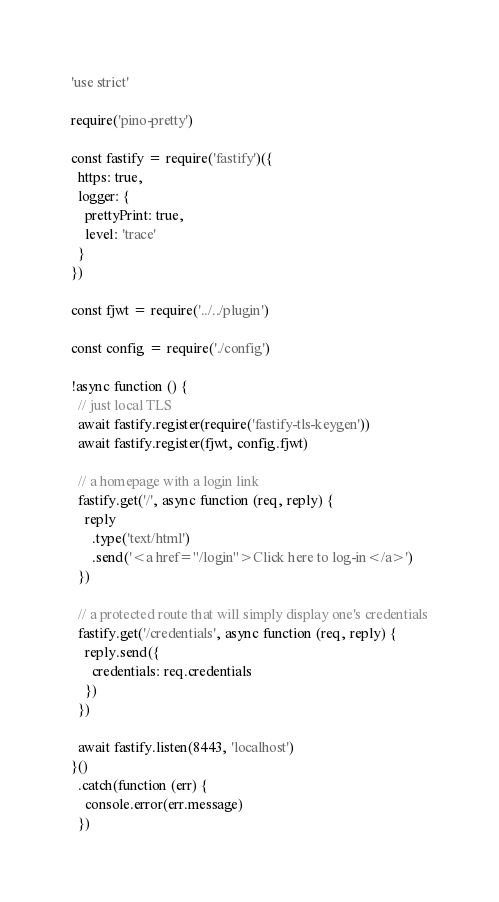<code> <loc_0><loc_0><loc_500><loc_500><_JavaScript_>'use strict'

require('pino-pretty')

const fastify = require('fastify')({
  https: true,
  logger: {
    prettyPrint: true,
    level: 'trace'
  }
})

const fjwt = require('../../plugin')

const config = require('./config')

!async function () {
  // just local TLS
  await fastify.register(require('fastify-tls-keygen'))
  await fastify.register(fjwt, config.fjwt)

  // a homepage with a login link
  fastify.get('/', async function (req, reply) {
    reply
      .type('text/html')
      .send('<a href="/login">Click here to log-in</a>')
  })

  // a protected route that will simply display one's credentials
  fastify.get('/credentials', async function (req, reply) {
    reply.send({
      credentials: req.credentials
    })
  })

  await fastify.listen(8443, 'localhost')
}()
  .catch(function (err) {
    console.error(err.message)
  })</code> 